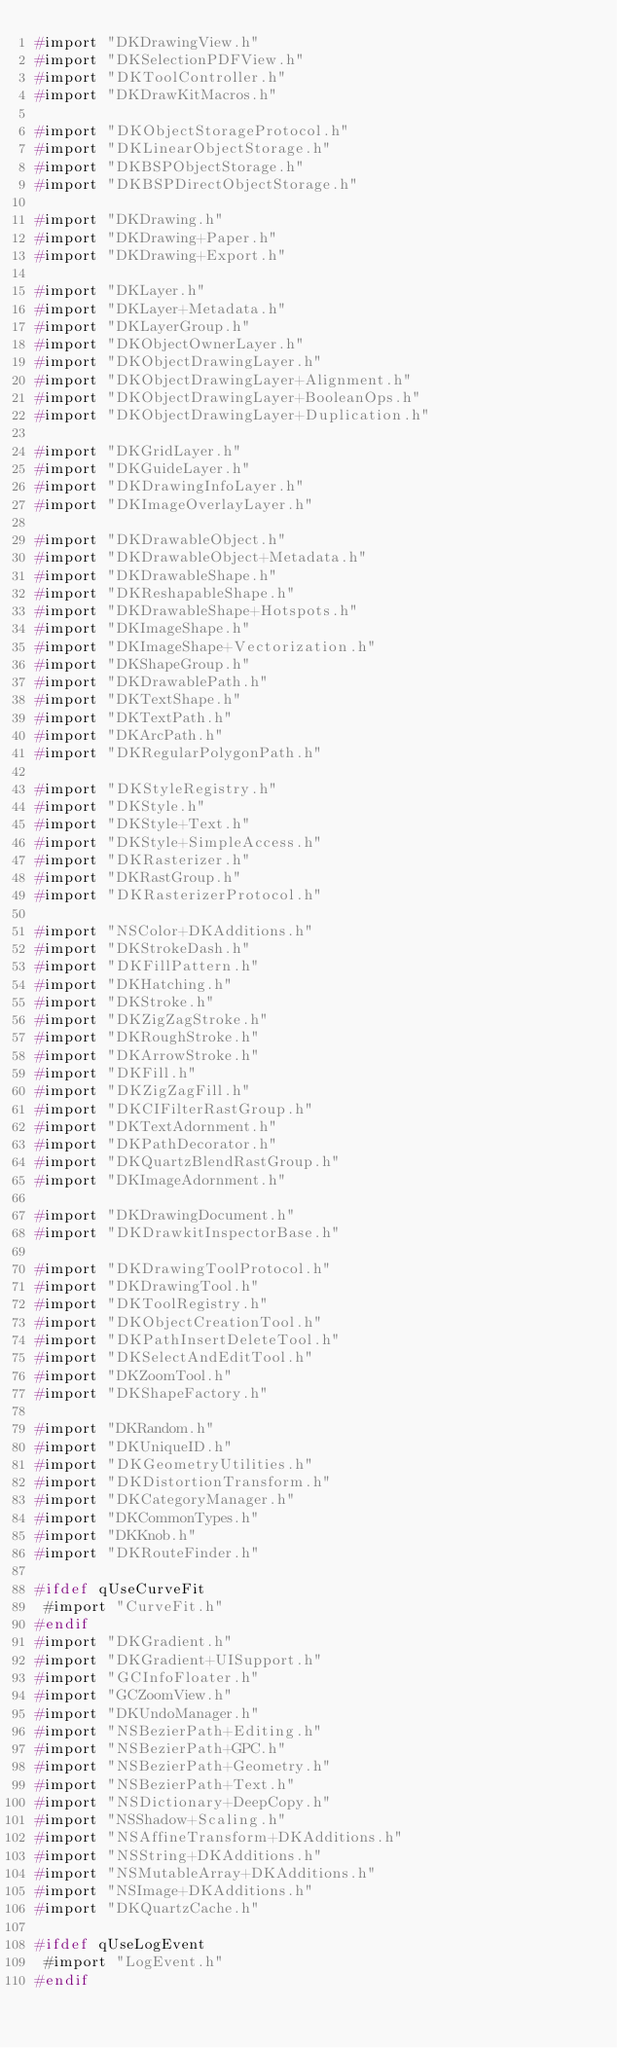<code> <loc_0><loc_0><loc_500><loc_500><_C_>#import "DKDrawingView.h"
#import "DKSelectionPDFView.h"
#import "DKToolController.h"
#import "DKDrawKitMacros.h"

#import "DKObjectStorageProtocol.h"
#import "DKLinearObjectStorage.h"
#import "DKBSPObjectStorage.h"
#import "DKBSPDirectObjectStorage.h"

#import "DKDrawing.h"
#import "DKDrawing+Paper.h"
#import "DKDrawing+Export.h"

#import "DKLayer.h"
#import "DKLayer+Metadata.h"
#import "DKLayerGroup.h"
#import "DKObjectOwnerLayer.h"
#import "DKObjectDrawingLayer.h"
#import "DKObjectDrawingLayer+Alignment.h"
#import "DKObjectDrawingLayer+BooleanOps.h"
#import "DKObjectDrawingLayer+Duplication.h"

#import "DKGridLayer.h"
#import "DKGuideLayer.h"
#import "DKDrawingInfoLayer.h"
#import "DKImageOverlayLayer.h"

#import "DKDrawableObject.h"
#import "DKDrawableObject+Metadata.h"
#import "DKDrawableShape.h"
#import "DKReshapableShape.h"
#import "DKDrawableShape+Hotspots.h"
#import "DKImageShape.h"
#import "DKImageShape+Vectorization.h"
#import "DKShapeGroup.h"
#import "DKDrawablePath.h"
#import "DKTextShape.h"
#import "DKTextPath.h"
#import "DKArcPath.h"
#import "DKRegularPolygonPath.h"

#import "DKStyleRegistry.h"
#import "DKStyle.h"
#import "DKStyle+Text.h"
#import "DKStyle+SimpleAccess.h"
#import "DKRasterizer.h"
#import "DKRastGroup.h"
#import "DKRasterizerProtocol.h"

#import "NSColor+DKAdditions.h"
#import "DKStrokeDash.h"
#import "DKFillPattern.h"
#import "DKHatching.h"
#import "DKStroke.h"
#import "DKZigZagStroke.h"
#import "DKRoughStroke.h"
#import "DKArrowStroke.h"
#import "DKFill.h"
#import "DKZigZagFill.h"
#import "DKCIFilterRastGroup.h"
#import "DKTextAdornment.h"
#import "DKPathDecorator.h"
#import "DKQuartzBlendRastGroup.h"
#import "DKImageAdornment.h"

#import "DKDrawingDocument.h"
#import "DKDrawkitInspectorBase.h"

#import "DKDrawingToolProtocol.h"
#import "DKDrawingTool.h"
#import "DKToolRegistry.h"
#import "DKObjectCreationTool.h"
#import "DKPathInsertDeleteTool.h"
#import "DKSelectAndEditTool.h"
#import "DKZoomTool.h"
#import "DKShapeFactory.h"

#import "DKRandom.h"
#import "DKUniqueID.h"
#import "DKGeometryUtilities.h"
#import "DKDistortionTransform.h"
#import "DKCategoryManager.h"
#import "DKCommonTypes.h"
#import "DKKnob.h"
#import "DKRouteFinder.h"

#ifdef qUseCurveFit
 #import "CurveFit.h"
#endif
#import "DKGradient.h"
#import "DKGradient+UISupport.h"
#import "GCInfoFloater.h"
#import "GCZoomView.h"
#import "DKUndoManager.h"
#import "NSBezierPath+Editing.h"
#import "NSBezierPath+GPC.h"
#import "NSBezierPath+Geometry.h"
#import "NSBezierPath+Text.h"
#import "NSDictionary+DeepCopy.h"
#import "NSShadow+Scaling.h"
#import "NSAffineTransform+DKAdditions.h"
#import "NSString+DKAdditions.h"
#import "NSMutableArray+DKAdditions.h"
#import "NSImage+DKAdditions.h"
#import "DKQuartzCache.h"

#ifdef qUseLogEvent
 #import "LogEvent.h"
#endif
</code> 